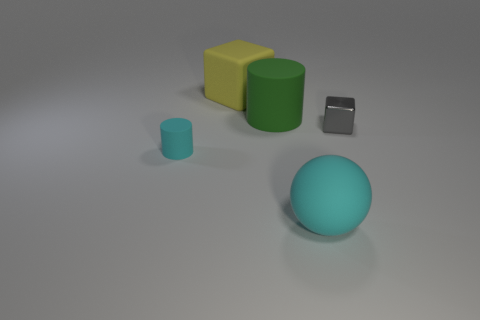Add 1 large green things. How many objects exist? 6 Subtract all balls. How many objects are left? 4 Subtract all big cylinders. Subtract all red rubber cylinders. How many objects are left? 4 Add 1 green rubber cylinders. How many green rubber cylinders are left? 2 Add 3 yellow matte cubes. How many yellow matte cubes exist? 4 Subtract 0 cyan cubes. How many objects are left? 5 